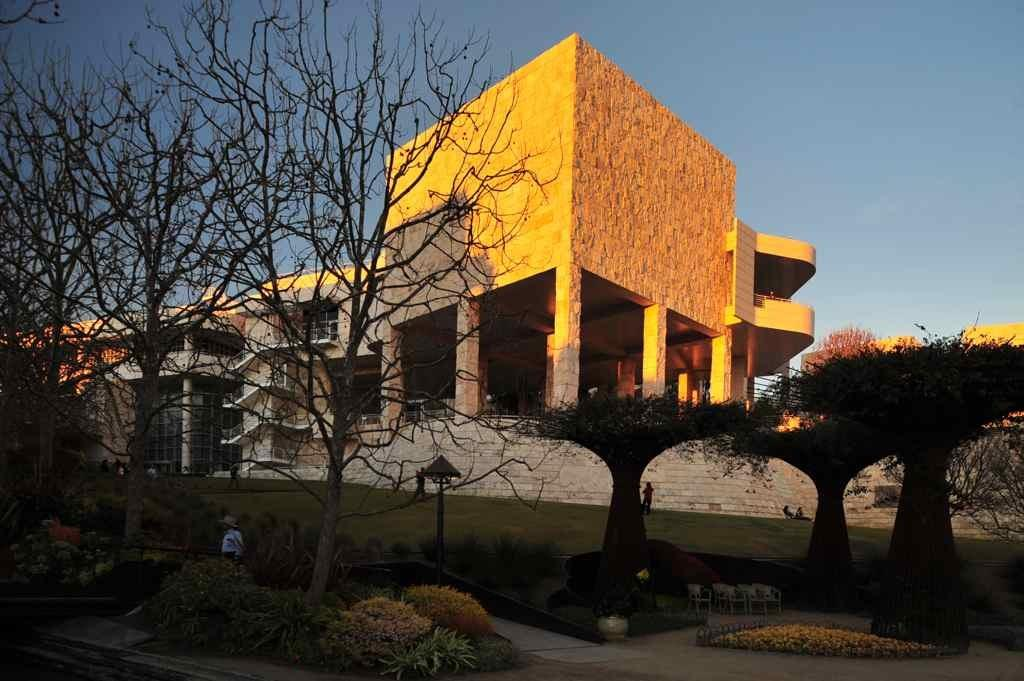What is the person in the image doing? The person is standing in the garden. What can be seen in the garden besides the person? There are trees in the garden. What is visible in the background of the image? There is a building and the clear sky visible in the background of the image. What type of trail is visible in the image? There is no trail visible in the image; it features a person standing in a garden with trees and a building in the background. 